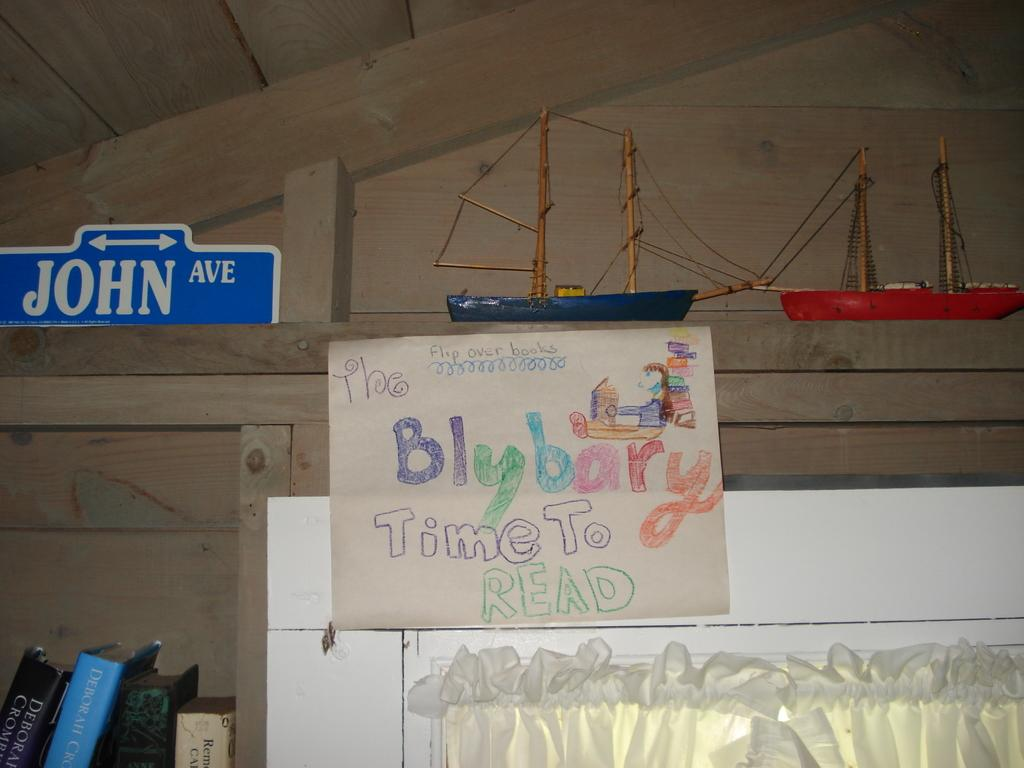<image>
Present a compact description of the photo's key features. Blue sign for JOHN Ave sitting near the ceiling next to a model boat. 